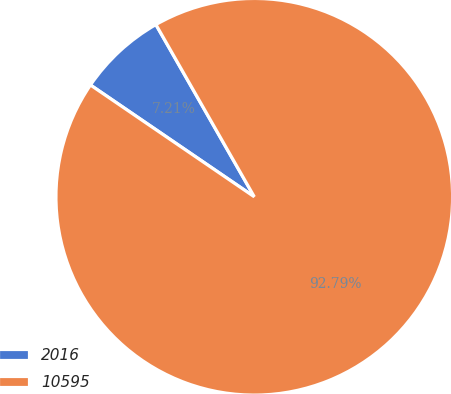Convert chart. <chart><loc_0><loc_0><loc_500><loc_500><pie_chart><fcel>2016<fcel>10595<nl><fcel>7.21%<fcel>92.79%<nl></chart> 